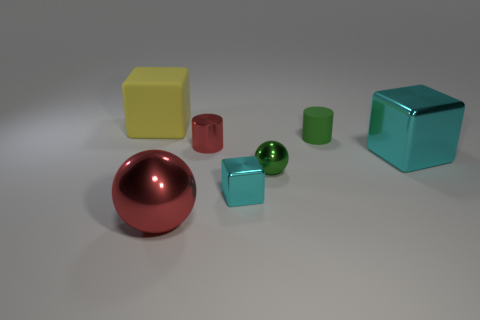There is a tiny cylinder that is the same color as the small metallic sphere; what is it made of?
Ensure brevity in your answer.  Rubber. Do the metal object to the left of the small red cylinder and the tiny shiny object behind the small shiny ball have the same color?
Your answer should be very brief. Yes. What number of rubber objects have the same size as the red cylinder?
Your answer should be compact. 1. There is a matte thing right of the yellow object; is it the same size as the big cyan metal object?
Make the answer very short. No. The yellow rubber object has what shape?
Provide a short and direct response. Cube. The ball that is the same color as the tiny metal cylinder is what size?
Your response must be concise. Large. Is the green thing behind the tiny red cylinder made of the same material as the large yellow object?
Keep it short and to the point. Yes. Are there any metal things that have the same color as the tiny block?
Your response must be concise. Yes. Is the shape of the matte thing left of the small green rubber cylinder the same as the cyan shiny thing left of the big cyan thing?
Ensure brevity in your answer.  Yes. Are there any big things made of the same material as the tiny block?
Provide a short and direct response. Yes. 